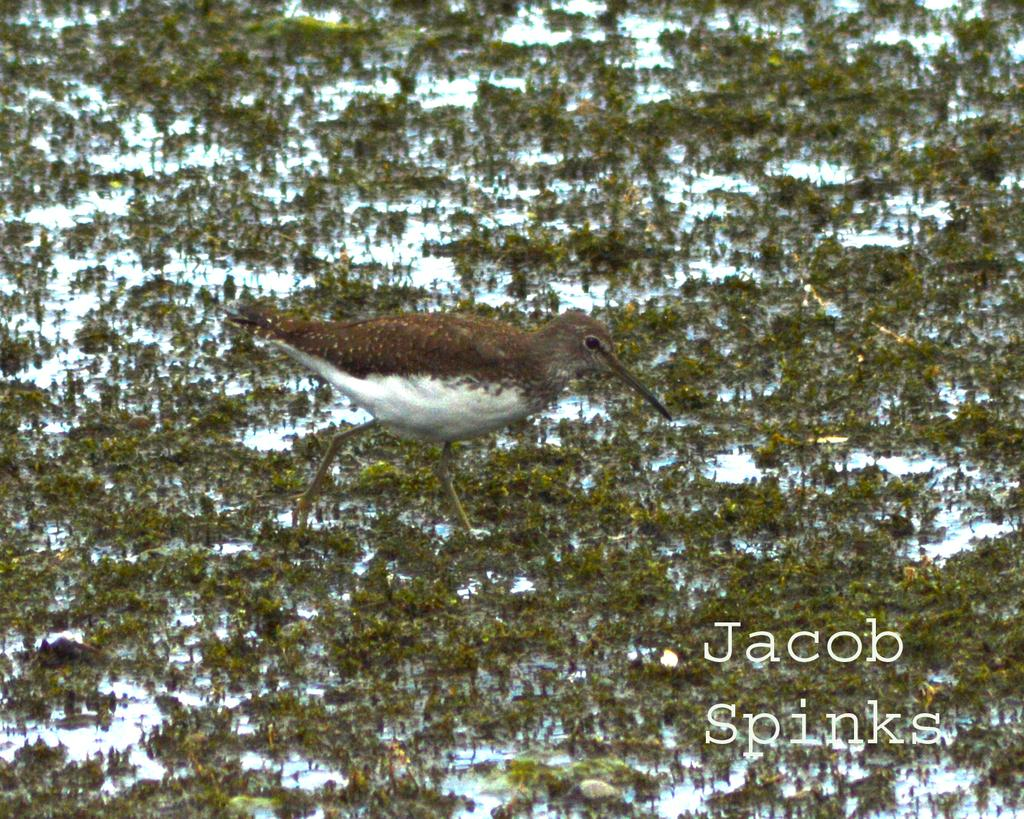What type of animal can be seen in the image? There is a bird in the image. What type of vegetation is visible in the image? There is grass visible in the image. Can you describe any additional features of the image? There is a watermark in the image. What month is depicted in the image? There is no specific month depicted in the image; it features a bird and grass. How many beds are visible in the image? There are no beds present in the image. 